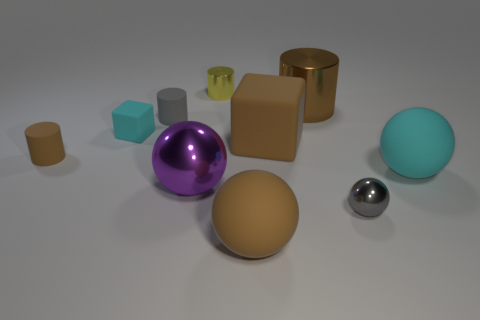Subtract 1 cylinders. How many cylinders are left? 3 Subtract all green spheres. Subtract all blue cylinders. How many spheres are left? 4 Subtract all cubes. How many objects are left? 8 Add 7 tiny cyan matte objects. How many tiny cyan matte objects exist? 8 Subtract 0 purple cylinders. How many objects are left? 10 Subtract all large yellow matte objects. Subtract all brown blocks. How many objects are left? 9 Add 7 tiny brown objects. How many tiny brown objects are left? 8 